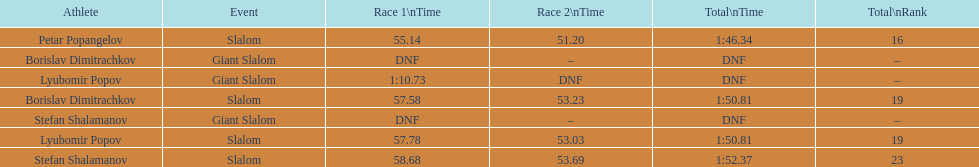Who was the other athlete who tied in rank with lyubomir popov? Borislav Dimitrachkov. 